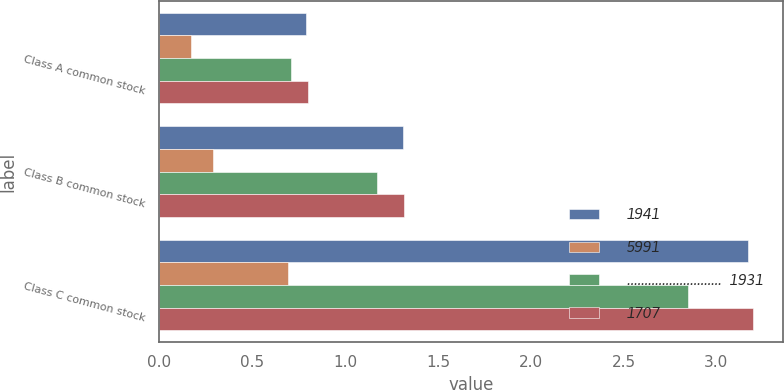<chart> <loc_0><loc_0><loc_500><loc_500><stacked_bar_chart><ecel><fcel>Class A common stock<fcel>Class B common stock<fcel>Class C common stock<nl><fcel>1941<fcel>0.79<fcel>1.31<fcel>3.17<nl><fcel>5991<fcel>0.17<fcel>0.29<fcel>0.69<nl><fcel>...........................  1931<fcel>0.71<fcel>1.17<fcel>2.85<nl><fcel>1707<fcel>0.8<fcel>1.32<fcel>3.2<nl></chart> 